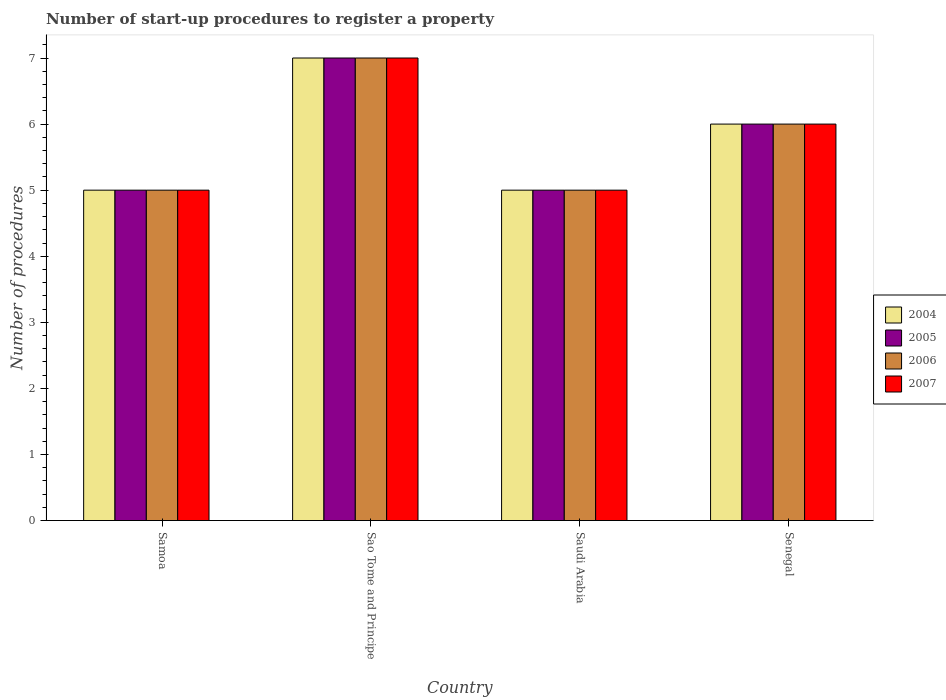How many different coloured bars are there?
Ensure brevity in your answer.  4. Are the number of bars on each tick of the X-axis equal?
Your response must be concise. Yes. How many bars are there on the 4th tick from the left?
Offer a very short reply. 4. How many bars are there on the 4th tick from the right?
Provide a short and direct response. 4. What is the label of the 1st group of bars from the left?
Provide a succinct answer. Samoa. In how many cases, is the number of bars for a given country not equal to the number of legend labels?
Offer a terse response. 0. What is the number of procedures required to register a property in 2004 in Saudi Arabia?
Offer a terse response. 5. Across all countries, what is the maximum number of procedures required to register a property in 2007?
Provide a short and direct response. 7. In which country was the number of procedures required to register a property in 2004 maximum?
Provide a succinct answer. Sao Tome and Principe. In which country was the number of procedures required to register a property in 2005 minimum?
Offer a terse response. Samoa. What is the total number of procedures required to register a property in 2005 in the graph?
Make the answer very short. 23. What is the difference between the number of procedures required to register a property in 2005 in Sao Tome and Principe and that in Senegal?
Provide a short and direct response. 1. What is the difference between the number of procedures required to register a property in 2005 in Saudi Arabia and the number of procedures required to register a property in 2004 in Senegal?
Your answer should be compact. -1. What is the average number of procedures required to register a property in 2004 per country?
Offer a terse response. 5.75. What is the difference between the number of procedures required to register a property of/in 2005 and number of procedures required to register a property of/in 2007 in Sao Tome and Principe?
Your response must be concise. 0. In how many countries, is the number of procedures required to register a property in 2006 greater than 2.2?
Your response must be concise. 4. What is the ratio of the number of procedures required to register a property in 2005 in Samoa to that in Sao Tome and Principe?
Make the answer very short. 0.71. Is the number of procedures required to register a property in 2006 in Saudi Arabia less than that in Senegal?
Offer a terse response. Yes. Is the difference between the number of procedures required to register a property in 2005 in Sao Tome and Principe and Saudi Arabia greater than the difference between the number of procedures required to register a property in 2007 in Sao Tome and Principe and Saudi Arabia?
Make the answer very short. No. What is the difference between the highest and the second highest number of procedures required to register a property in 2004?
Your answer should be compact. -1. Is the sum of the number of procedures required to register a property in 2004 in Samoa and Saudi Arabia greater than the maximum number of procedures required to register a property in 2005 across all countries?
Keep it short and to the point. Yes. Is it the case that in every country, the sum of the number of procedures required to register a property in 2006 and number of procedures required to register a property in 2004 is greater than the sum of number of procedures required to register a property in 2007 and number of procedures required to register a property in 2005?
Your answer should be compact. No. What is the difference between two consecutive major ticks on the Y-axis?
Offer a very short reply. 1. Are the values on the major ticks of Y-axis written in scientific E-notation?
Make the answer very short. No. Does the graph contain any zero values?
Offer a terse response. No. How many legend labels are there?
Your answer should be compact. 4. How are the legend labels stacked?
Provide a succinct answer. Vertical. What is the title of the graph?
Your answer should be very brief. Number of start-up procedures to register a property. What is the label or title of the X-axis?
Give a very brief answer. Country. What is the label or title of the Y-axis?
Provide a short and direct response. Number of procedures. What is the Number of procedures in 2004 in Samoa?
Give a very brief answer. 5. What is the Number of procedures in 2005 in Samoa?
Your response must be concise. 5. What is the Number of procedures in 2007 in Samoa?
Keep it short and to the point. 5. What is the Number of procedures of 2005 in Sao Tome and Principe?
Your answer should be compact. 7. What is the Number of procedures of 2006 in Sao Tome and Principe?
Your answer should be compact. 7. What is the Number of procedures of 2007 in Sao Tome and Principe?
Ensure brevity in your answer.  7. What is the Number of procedures in 2004 in Saudi Arabia?
Your response must be concise. 5. What is the Number of procedures of 2006 in Saudi Arabia?
Keep it short and to the point. 5. What is the Number of procedures of 2007 in Saudi Arabia?
Keep it short and to the point. 5. What is the Number of procedures in 2004 in Senegal?
Ensure brevity in your answer.  6. What is the Number of procedures of 2005 in Senegal?
Provide a short and direct response. 6. What is the Number of procedures of 2007 in Senegal?
Provide a short and direct response. 6. Across all countries, what is the maximum Number of procedures of 2004?
Make the answer very short. 7. Across all countries, what is the maximum Number of procedures of 2006?
Offer a terse response. 7. Across all countries, what is the maximum Number of procedures of 2007?
Offer a terse response. 7. Across all countries, what is the minimum Number of procedures of 2004?
Give a very brief answer. 5. Across all countries, what is the minimum Number of procedures in 2006?
Give a very brief answer. 5. Across all countries, what is the minimum Number of procedures of 2007?
Give a very brief answer. 5. What is the total Number of procedures in 2005 in the graph?
Keep it short and to the point. 23. What is the total Number of procedures of 2006 in the graph?
Offer a very short reply. 23. What is the total Number of procedures in 2007 in the graph?
Offer a terse response. 23. What is the difference between the Number of procedures of 2004 in Samoa and that in Sao Tome and Principe?
Keep it short and to the point. -2. What is the difference between the Number of procedures in 2007 in Samoa and that in Sao Tome and Principe?
Provide a short and direct response. -2. What is the difference between the Number of procedures of 2004 in Samoa and that in Saudi Arabia?
Offer a terse response. 0. What is the difference between the Number of procedures in 2006 in Samoa and that in Saudi Arabia?
Make the answer very short. 0. What is the difference between the Number of procedures of 2004 in Samoa and that in Senegal?
Provide a succinct answer. -1. What is the difference between the Number of procedures in 2006 in Samoa and that in Senegal?
Ensure brevity in your answer.  -1. What is the difference between the Number of procedures of 2007 in Samoa and that in Senegal?
Provide a short and direct response. -1. What is the difference between the Number of procedures in 2005 in Sao Tome and Principe and that in Saudi Arabia?
Your answer should be very brief. 2. What is the difference between the Number of procedures in 2005 in Sao Tome and Principe and that in Senegal?
Ensure brevity in your answer.  1. What is the difference between the Number of procedures of 2006 in Sao Tome and Principe and that in Senegal?
Your response must be concise. 1. What is the difference between the Number of procedures of 2004 in Saudi Arabia and that in Senegal?
Provide a short and direct response. -1. What is the difference between the Number of procedures of 2005 in Saudi Arabia and that in Senegal?
Keep it short and to the point. -1. What is the difference between the Number of procedures in 2004 in Samoa and the Number of procedures in 2006 in Sao Tome and Principe?
Keep it short and to the point. -2. What is the difference between the Number of procedures in 2005 in Samoa and the Number of procedures in 2007 in Sao Tome and Principe?
Provide a short and direct response. -2. What is the difference between the Number of procedures in 2004 in Samoa and the Number of procedures in 2005 in Saudi Arabia?
Your answer should be very brief. 0. What is the difference between the Number of procedures in 2005 in Samoa and the Number of procedures in 2007 in Saudi Arabia?
Provide a short and direct response. 0. What is the difference between the Number of procedures in 2004 in Samoa and the Number of procedures in 2006 in Senegal?
Provide a short and direct response. -1. What is the difference between the Number of procedures in 2004 in Samoa and the Number of procedures in 2007 in Senegal?
Give a very brief answer. -1. What is the difference between the Number of procedures in 2005 in Samoa and the Number of procedures in 2006 in Senegal?
Offer a very short reply. -1. What is the difference between the Number of procedures in 2005 in Samoa and the Number of procedures in 2007 in Senegal?
Offer a very short reply. -1. What is the difference between the Number of procedures of 2004 in Sao Tome and Principe and the Number of procedures of 2006 in Saudi Arabia?
Keep it short and to the point. 2. What is the difference between the Number of procedures in 2004 in Sao Tome and Principe and the Number of procedures in 2007 in Saudi Arabia?
Provide a short and direct response. 2. What is the difference between the Number of procedures of 2004 in Sao Tome and Principe and the Number of procedures of 2005 in Senegal?
Your response must be concise. 1. What is the difference between the Number of procedures in 2005 in Sao Tome and Principe and the Number of procedures in 2006 in Senegal?
Provide a short and direct response. 1. What is the difference between the Number of procedures of 2005 in Sao Tome and Principe and the Number of procedures of 2007 in Senegal?
Ensure brevity in your answer.  1. What is the difference between the Number of procedures in 2004 in Saudi Arabia and the Number of procedures in 2005 in Senegal?
Your response must be concise. -1. What is the difference between the Number of procedures of 2004 in Saudi Arabia and the Number of procedures of 2006 in Senegal?
Keep it short and to the point. -1. What is the difference between the Number of procedures of 2004 in Saudi Arabia and the Number of procedures of 2007 in Senegal?
Provide a succinct answer. -1. What is the difference between the Number of procedures of 2005 in Saudi Arabia and the Number of procedures of 2006 in Senegal?
Provide a short and direct response. -1. What is the difference between the Number of procedures of 2005 in Saudi Arabia and the Number of procedures of 2007 in Senegal?
Provide a short and direct response. -1. What is the difference between the Number of procedures of 2006 in Saudi Arabia and the Number of procedures of 2007 in Senegal?
Your answer should be very brief. -1. What is the average Number of procedures of 2004 per country?
Provide a short and direct response. 5.75. What is the average Number of procedures of 2005 per country?
Offer a very short reply. 5.75. What is the average Number of procedures in 2006 per country?
Make the answer very short. 5.75. What is the average Number of procedures in 2007 per country?
Make the answer very short. 5.75. What is the difference between the Number of procedures of 2004 and Number of procedures of 2005 in Samoa?
Make the answer very short. 0. What is the difference between the Number of procedures in 2004 and Number of procedures in 2006 in Samoa?
Give a very brief answer. 0. What is the difference between the Number of procedures in 2004 and Number of procedures in 2007 in Samoa?
Offer a terse response. 0. What is the difference between the Number of procedures of 2006 and Number of procedures of 2007 in Samoa?
Make the answer very short. 0. What is the difference between the Number of procedures in 2004 and Number of procedures in 2005 in Sao Tome and Principe?
Ensure brevity in your answer.  0. What is the difference between the Number of procedures of 2004 and Number of procedures of 2006 in Sao Tome and Principe?
Provide a succinct answer. 0. What is the difference between the Number of procedures of 2005 and Number of procedures of 2006 in Sao Tome and Principe?
Provide a short and direct response. 0. What is the difference between the Number of procedures in 2006 and Number of procedures in 2007 in Sao Tome and Principe?
Provide a succinct answer. 0. What is the difference between the Number of procedures in 2004 and Number of procedures in 2005 in Saudi Arabia?
Give a very brief answer. 0. What is the difference between the Number of procedures of 2005 and Number of procedures of 2006 in Saudi Arabia?
Offer a terse response. 0. What is the difference between the Number of procedures of 2005 and Number of procedures of 2007 in Saudi Arabia?
Offer a very short reply. 0. What is the difference between the Number of procedures of 2004 and Number of procedures of 2005 in Senegal?
Offer a very short reply. 0. What is the difference between the Number of procedures in 2005 and Number of procedures in 2006 in Senegal?
Provide a short and direct response. 0. What is the difference between the Number of procedures of 2005 and Number of procedures of 2007 in Senegal?
Provide a short and direct response. 0. What is the difference between the Number of procedures in 2006 and Number of procedures in 2007 in Senegal?
Keep it short and to the point. 0. What is the ratio of the Number of procedures of 2006 in Samoa to that in Sao Tome and Principe?
Offer a very short reply. 0.71. What is the ratio of the Number of procedures in 2004 in Samoa to that in Saudi Arabia?
Offer a terse response. 1. What is the ratio of the Number of procedures in 2005 in Samoa to that in Saudi Arabia?
Offer a very short reply. 1. What is the ratio of the Number of procedures of 2004 in Samoa to that in Senegal?
Give a very brief answer. 0.83. What is the ratio of the Number of procedures of 2005 in Samoa to that in Senegal?
Your response must be concise. 0.83. What is the ratio of the Number of procedures of 2007 in Samoa to that in Senegal?
Keep it short and to the point. 0.83. What is the ratio of the Number of procedures of 2004 in Sao Tome and Principe to that in Saudi Arabia?
Your answer should be very brief. 1.4. What is the ratio of the Number of procedures of 2005 in Sao Tome and Principe to that in Saudi Arabia?
Offer a very short reply. 1.4. What is the ratio of the Number of procedures in 2006 in Sao Tome and Principe to that in Saudi Arabia?
Your answer should be compact. 1.4. What is the ratio of the Number of procedures in 2004 in Sao Tome and Principe to that in Senegal?
Your response must be concise. 1.17. What is the ratio of the Number of procedures of 2005 in Sao Tome and Principe to that in Senegal?
Offer a very short reply. 1.17. What is the ratio of the Number of procedures of 2007 in Sao Tome and Principe to that in Senegal?
Make the answer very short. 1.17. What is the ratio of the Number of procedures in 2006 in Saudi Arabia to that in Senegal?
Your response must be concise. 0.83. What is the difference between the highest and the second highest Number of procedures of 2006?
Your answer should be compact. 1. What is the difference between the highest and the lowest Number of procedures in 2007?
Your answer should be very brief. 2. 